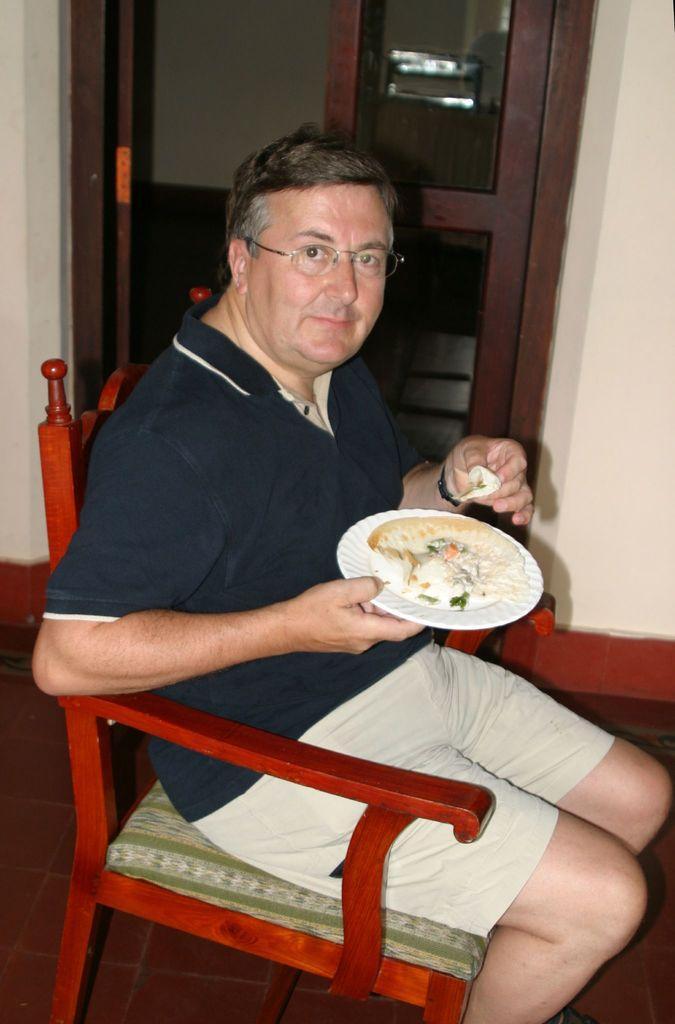Could you give a brief overview of what you see in this image? In this picture we can see man wore spectacle holding plate in his hand with some food sitting on chair and smiling and in background we can see door, wall. 